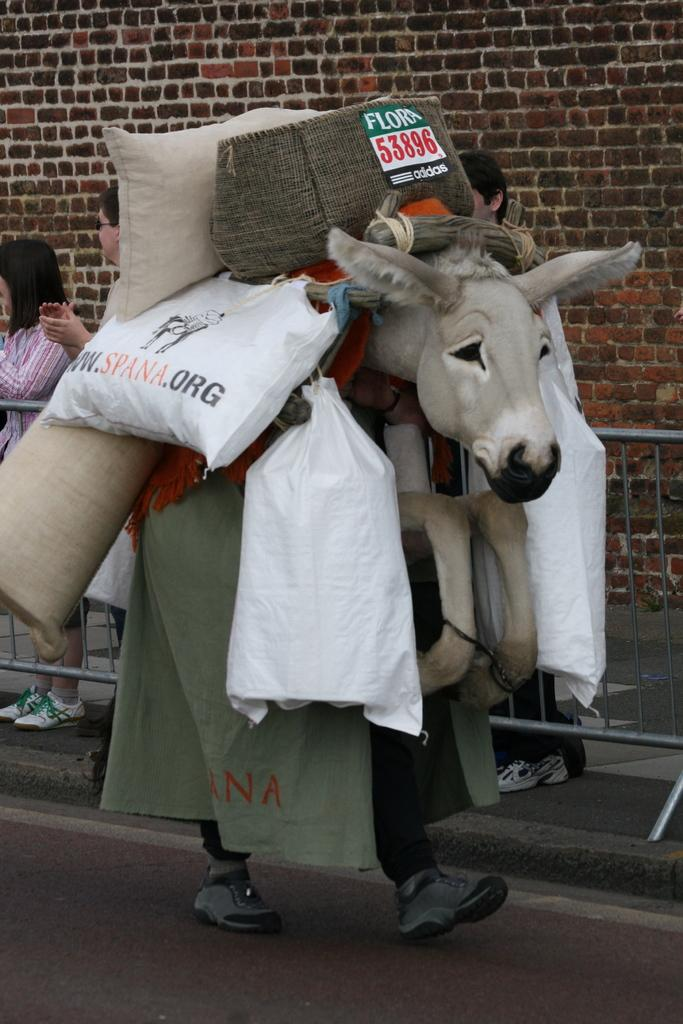What is happening in the image? There is a person in the image who is walking on the road. What is the person wearing? The person is wearing a donkey's mask. What is the person carrying? The person is carrying goods. What can be seen in the background of the image? There is a wall in the background, and there are persons standing behind a grill. What type of breakfast is the person eating in the image? There is no indication in the image that the person is eating breakfast, as the focus is on the person walking on the road and wearing a donkey's mask. 